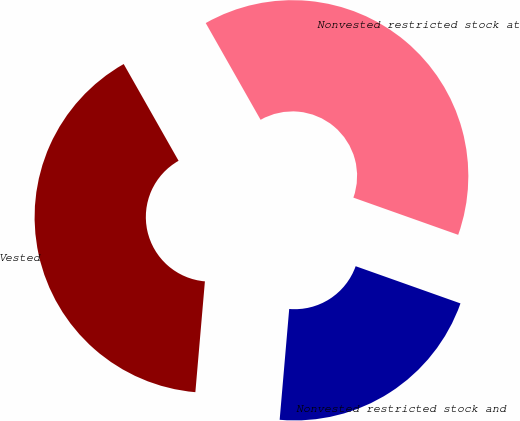Convert chart. <chart><loc_0><loc_0><loc_500><loc_500><pie_chart><fcel>Nonvested restricted stock at<fcel>Vested<fcel>Nonvested restricted stock and<nl><fcel>38.64%<fcel>40.42%<fcel>20.94%<nl></chart> 